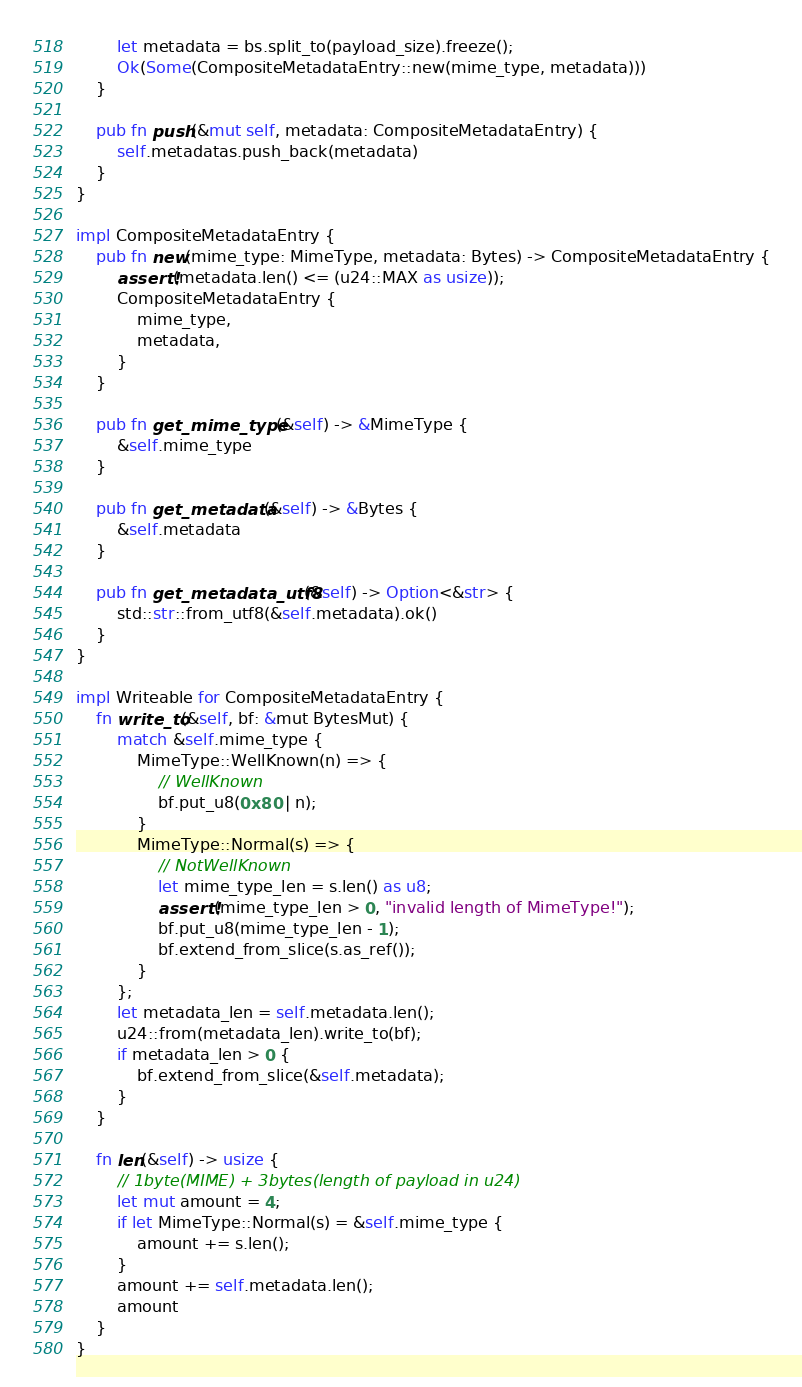Convert code to text. <code><loc_0><loc_0><loc_500><loc_500><_Rust_>        let metadata = bs.split_to(payload_size).freeze();
        Ok(Some(CompositeMetadataEntry::new(mime_type, metadata)))
    }

    pub fn push(&mut self, metadata: CompositeMetadataEntry) {
        self.metadatas.push_back(metadata)
    }
}

impl CompositeMetadataEntry {
    pub fn new(mime_type: MimeType, metadata: Bytes) -> CompositeMetadataEntry {
        assert!(metadata.len() <= (u24::MAX as usize));
        CompositeMetadataEntry {
            mime_type,
            metadata,
        }
    }

    pub fn get_mime_type(&self) -> &MimeType {
        &self.mime_type
    }

    pub fn get_metadata(&self) -> &Bytes {
        &self.metadata
    }

    pub fn get_metadata_utf8(&self) -> Option<&str> {
        std::str::from_utf8(&self.metadata).ok()
    }
}

impl Writeable for CompositeMetadataEntry {
    fn write_to(&self, bf: &mut BytesMut) {
        match &self.mime_type {
            MimeType::WellKnown(n) => {
                // WellKnown
                bf.put_u8(0x80 | n);
            }
            MimeType::Normal(s) => {
                // NotWellKnown
                let mime_type_len = s.len() as u8;
                assert!(mime_type_len > 0, "invalid length of MimeType!");
                bf.put_u8(mime_type_len - 1);
                bf.extend_from_slice(s.as_ref());
            }
        };
        let metadata_len = self.metadata.len();
        u24::from(metadata_len).write_to(bf);
        if metadata_len > 0 {
            bf.extend_from_slice(&self.metadata);
        }
    }

    fn len(&self) -> usize {
        // 1byte(MIME) + 3bytes(length of payload in u24)
        let mut amount = 4;
        if let MimeType::Normal(s) = &self.mime_type {
            amount += s.len();
        }
        amount += self.metadata.len();
        amount
    }
}
</code> 